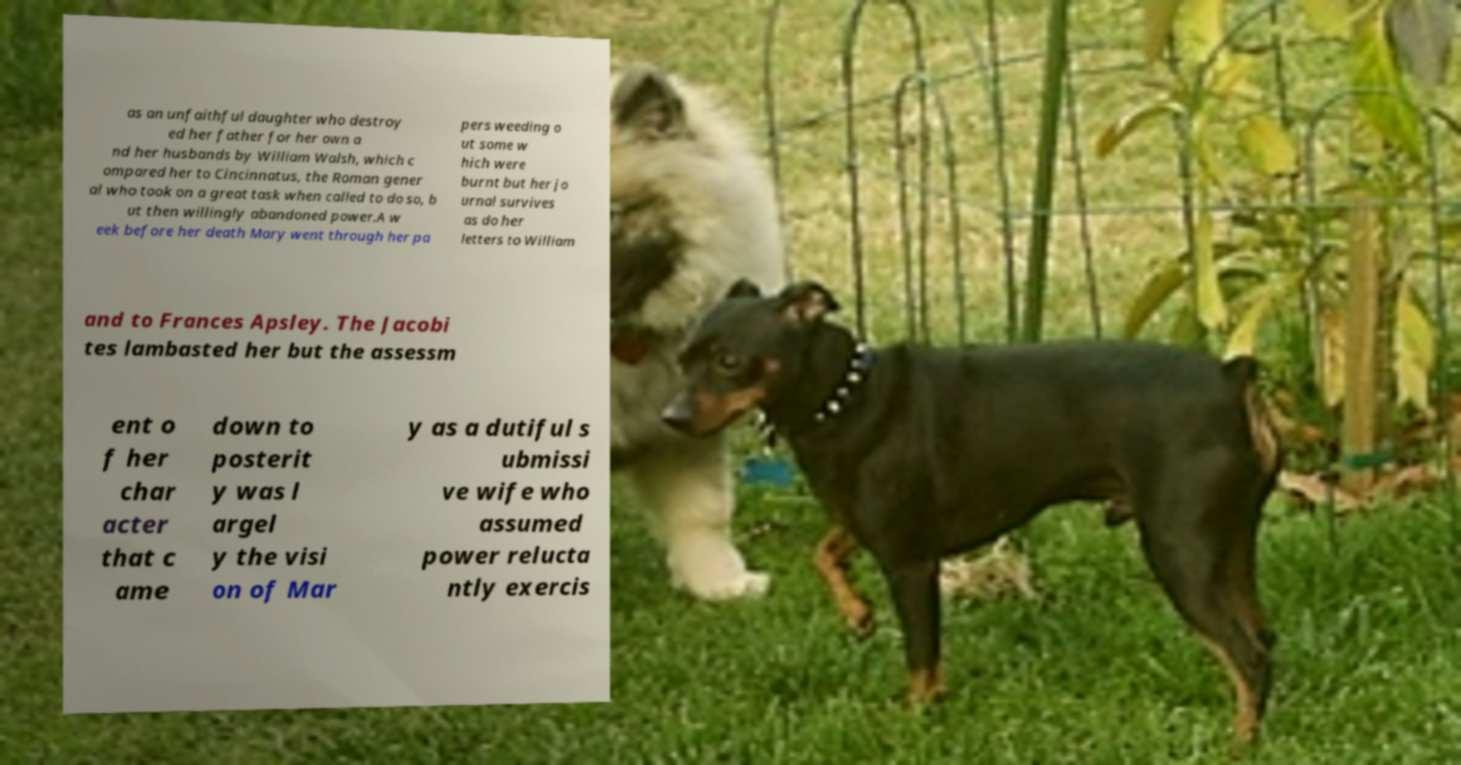Can you accurately transcribe the text from the provided image for me? as an unfaithful daughter who destroy ed her father for her own a nd her husbands by William Walsh, which c ompared her to Cincinnatus, the Roman gener al who took on a great task when called to do so, b ut then willingly abandoned power.A w eek before her death Mary went through her pa pers weeding o ut some w hich were burnt but her jo urnal survives as do her letters to William and to Frances Apsley. The Jacobi tes lambasted her but the assessm ent o f her char acter that c ame down to posterit y was l argel y the visi on of Mar y as a dutiful s ubmissi ve wife who assumed power relucta ntly exercis 